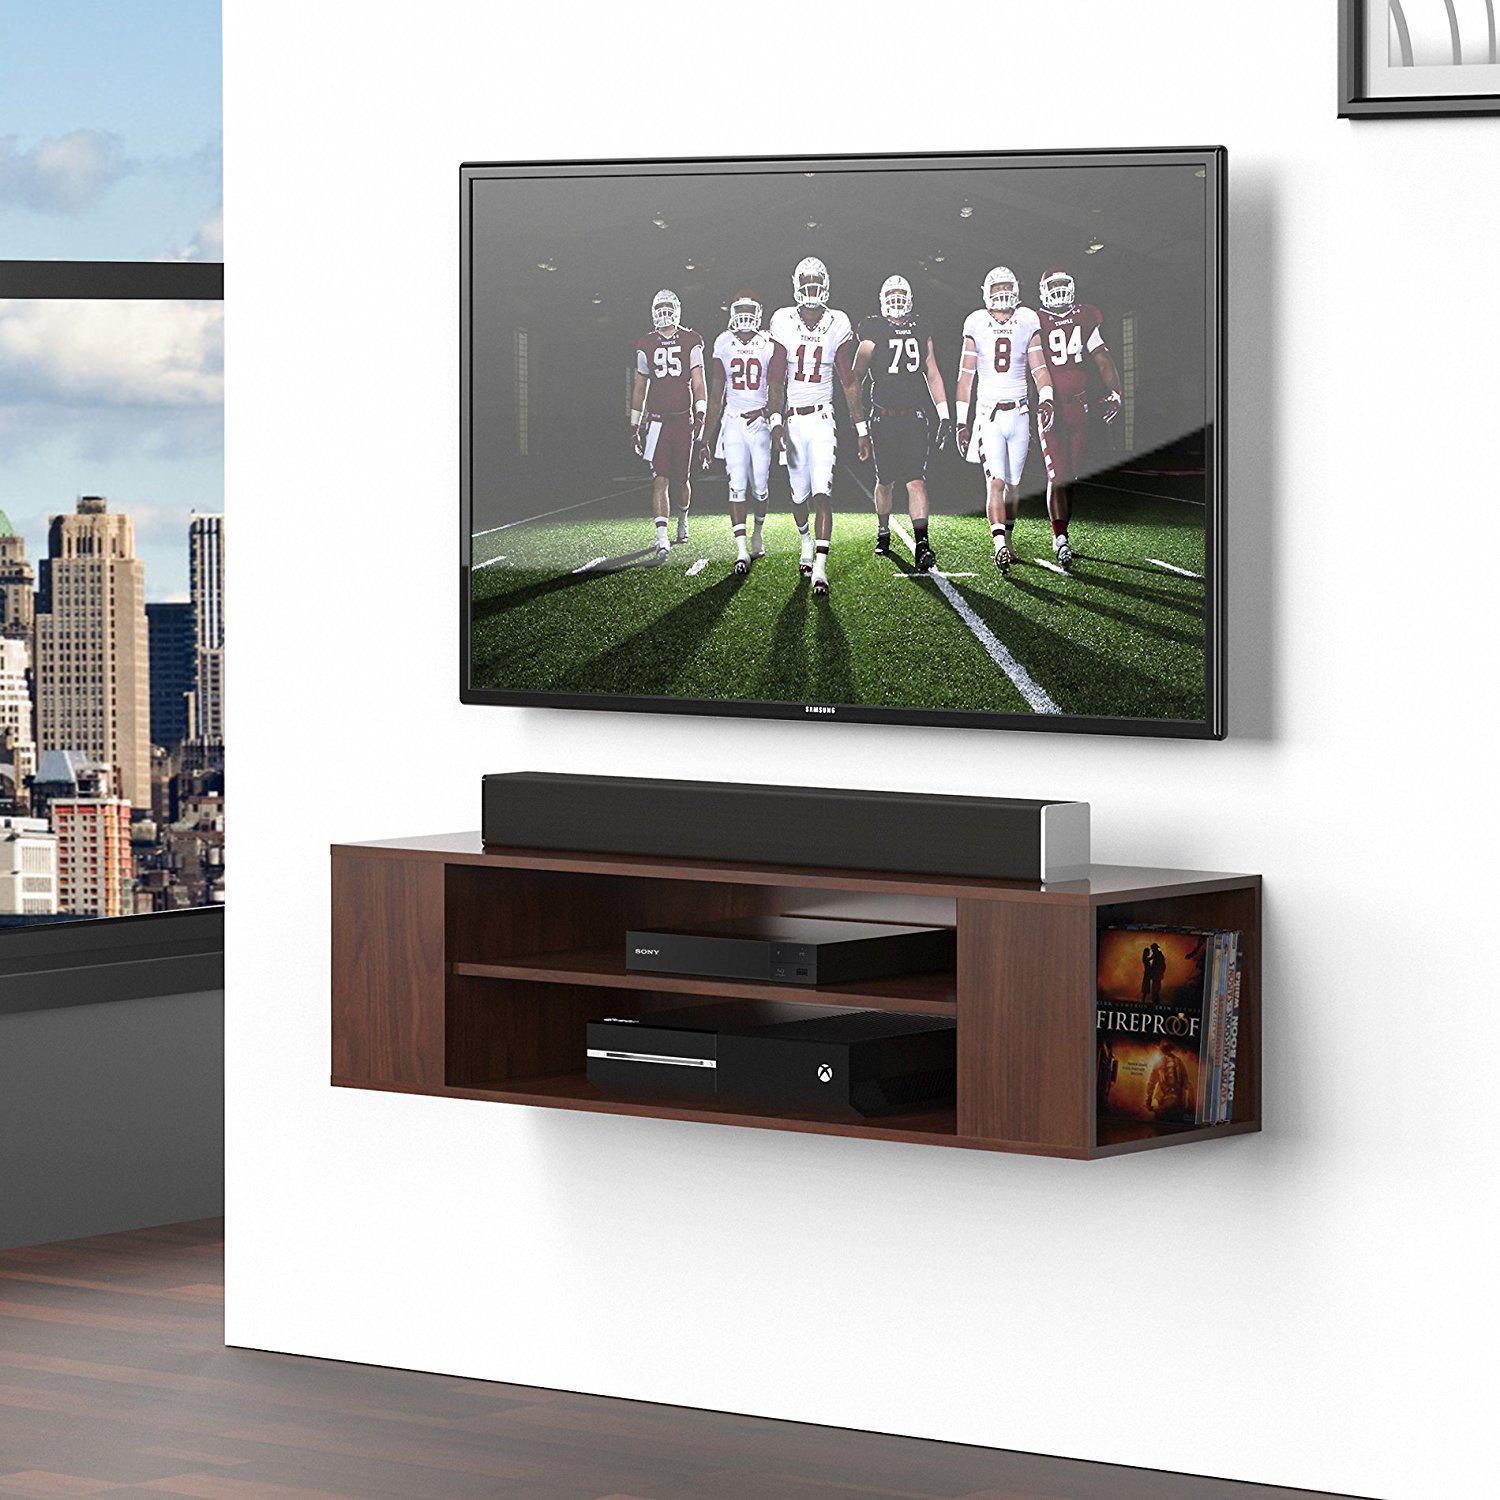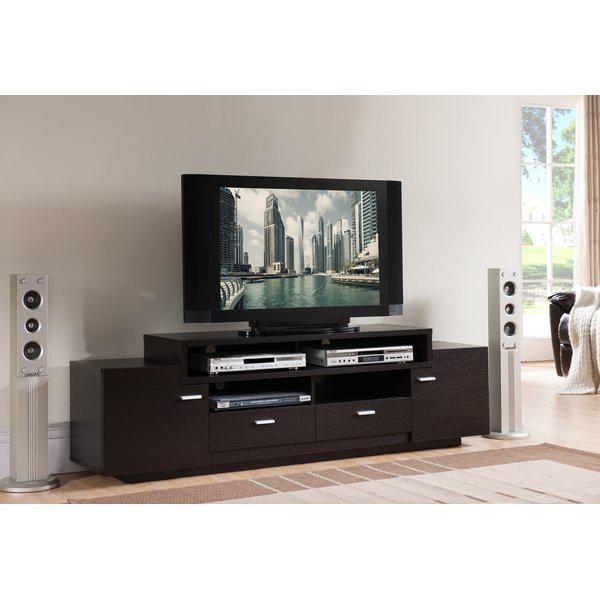The first image is the image on the left, the second image is the image on the right. Considering the images on both sides, is "One of the images shows a TV that is not mounted to the wall." valid? Answer yes or no. Yes. The first image is the image on the left, the second image is the image on the right. Analyze the images presented: Is the assertion "At least one image shows some type of green plant near a flat-screen TV, and exactly one image contains a TV with a picture on its screen." valid? Answer yes or no. No. 